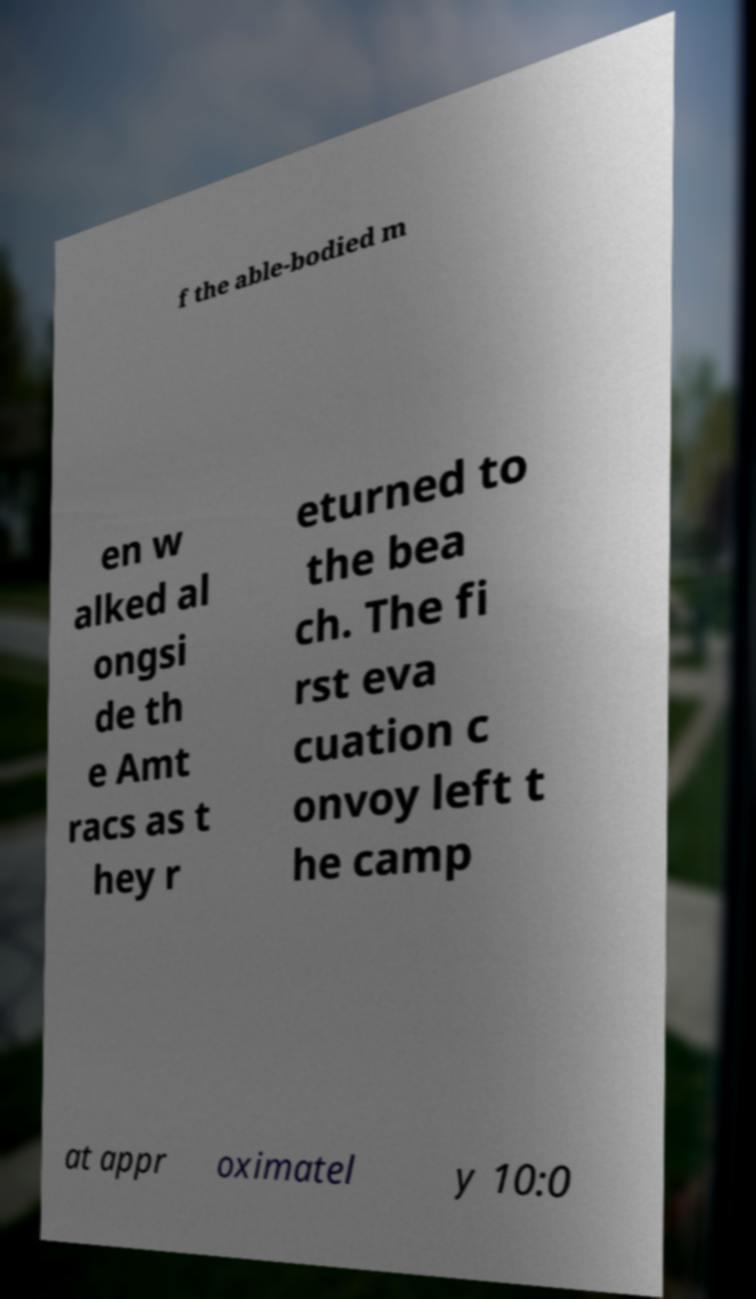For documentation purposes, I need the text within this image transcribed. Could you provide that? f the able-bodied m en w alked al ongsi de th e Amt racs as t hey r eturned to the bea ch. The fi rst eva cuation c onvoy left t he camp at appr oximatel y 10:0 